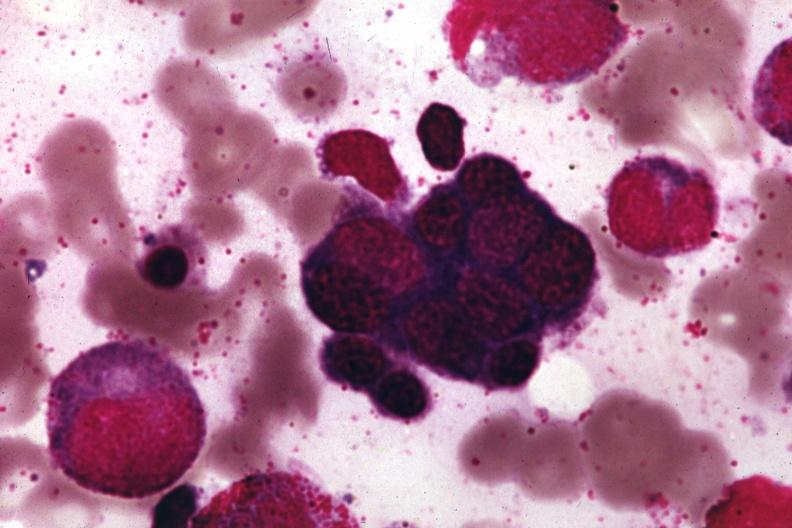what is present?
Answer the question using a single word or phrase. Bone marrow 